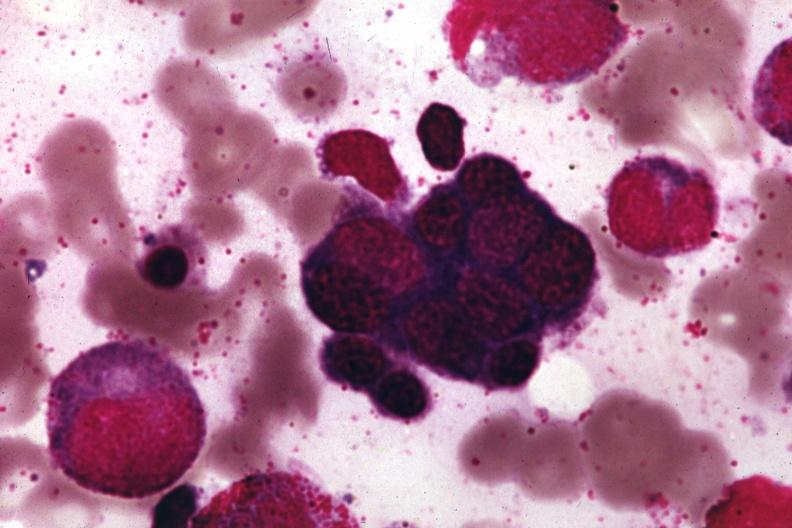what is present?
Answer the question using a single word or phrase. Bone marrow 